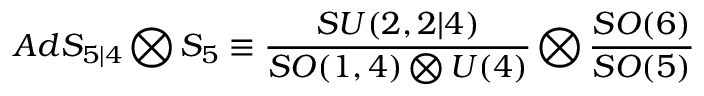<formula> <loc_0><loc_0><loc_500><loc_500>A d S _ { 5 | 4 } \bigotimes S _ { 5 } \equiv \frac { S U ( 2 , 2 | 4 ) } { S O ( 1 , 4 ) \bigotimes U ( 4 ) } \bigotimes \frac { S O ( 6 ) } { S O ( 5 ) }</formula> 